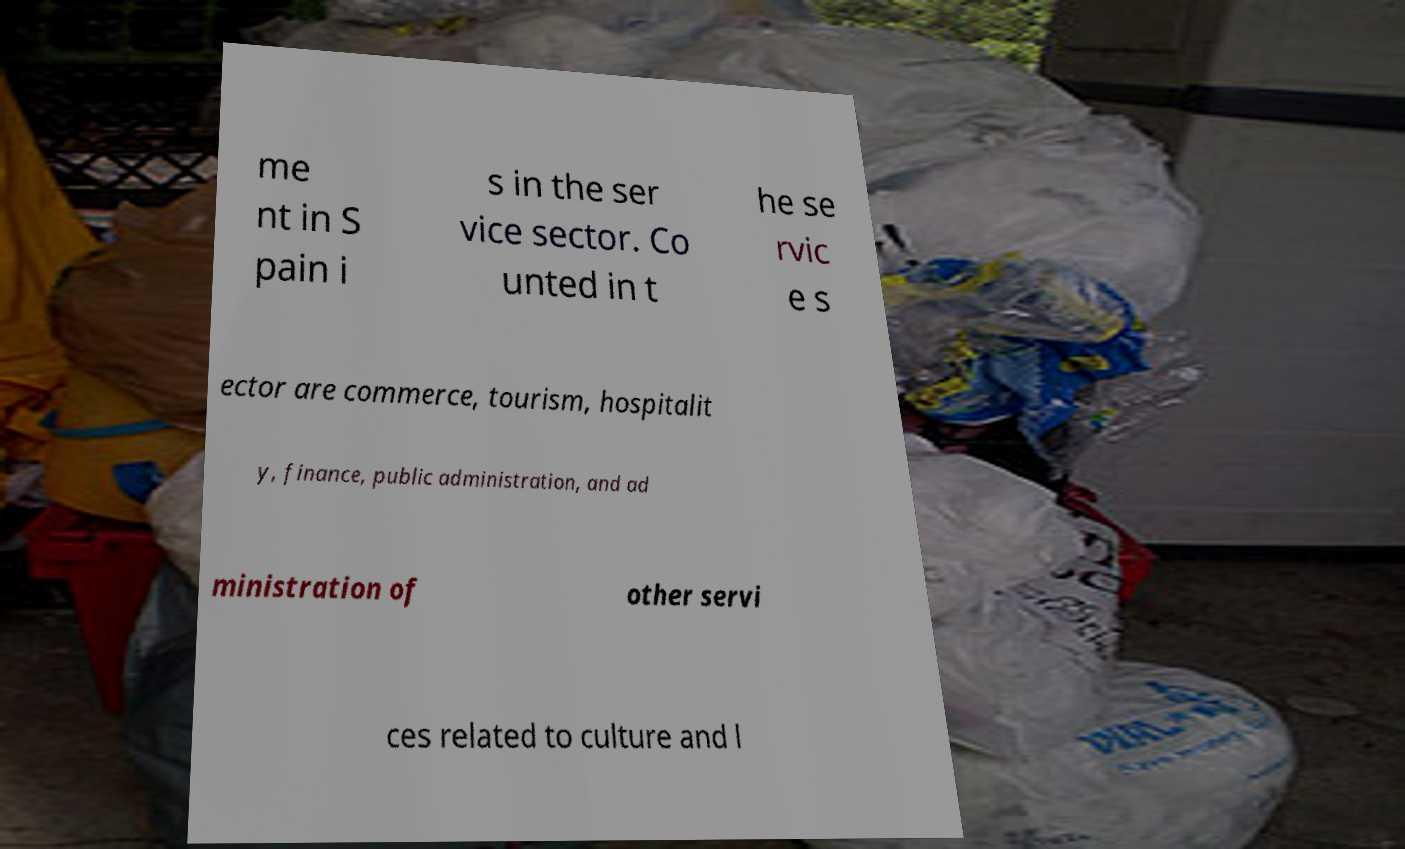Could you extract and type out the text from this image? me nt in S pain i s in the ser vice sector. Co unted in t he se rvic e s ector are commerce, tourism, hospitalit y, finance, public administration, and ad ministration of other servi ces related to culture and l 